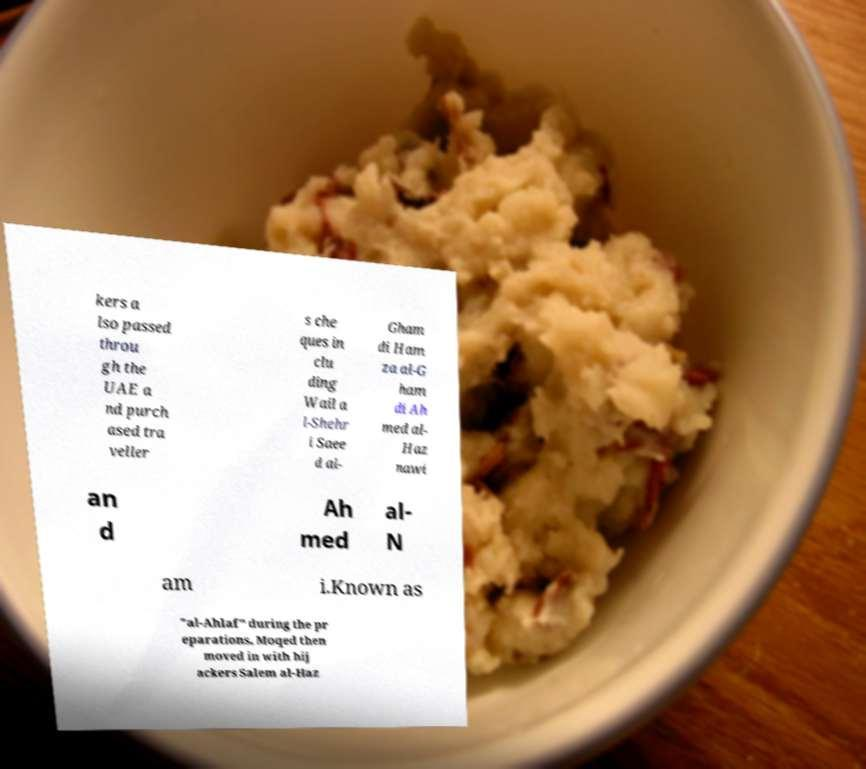Can you read and provide the text displayed in the image?This photo seems to have some interesting text. Can you extract and type it out for me? kers a lso passed throu gh the UAE a nd purch ased tra veller s che ques in clu ding Wail a l-Shehr i Saee d al- Gham di Ham za al-G ham di Ah med al- Haz nawi an d Ah med al- N am i.Known as "al-Ahlaf" during the pr eparations, Moqed then moved in with hij ackers Salem al-Haz 